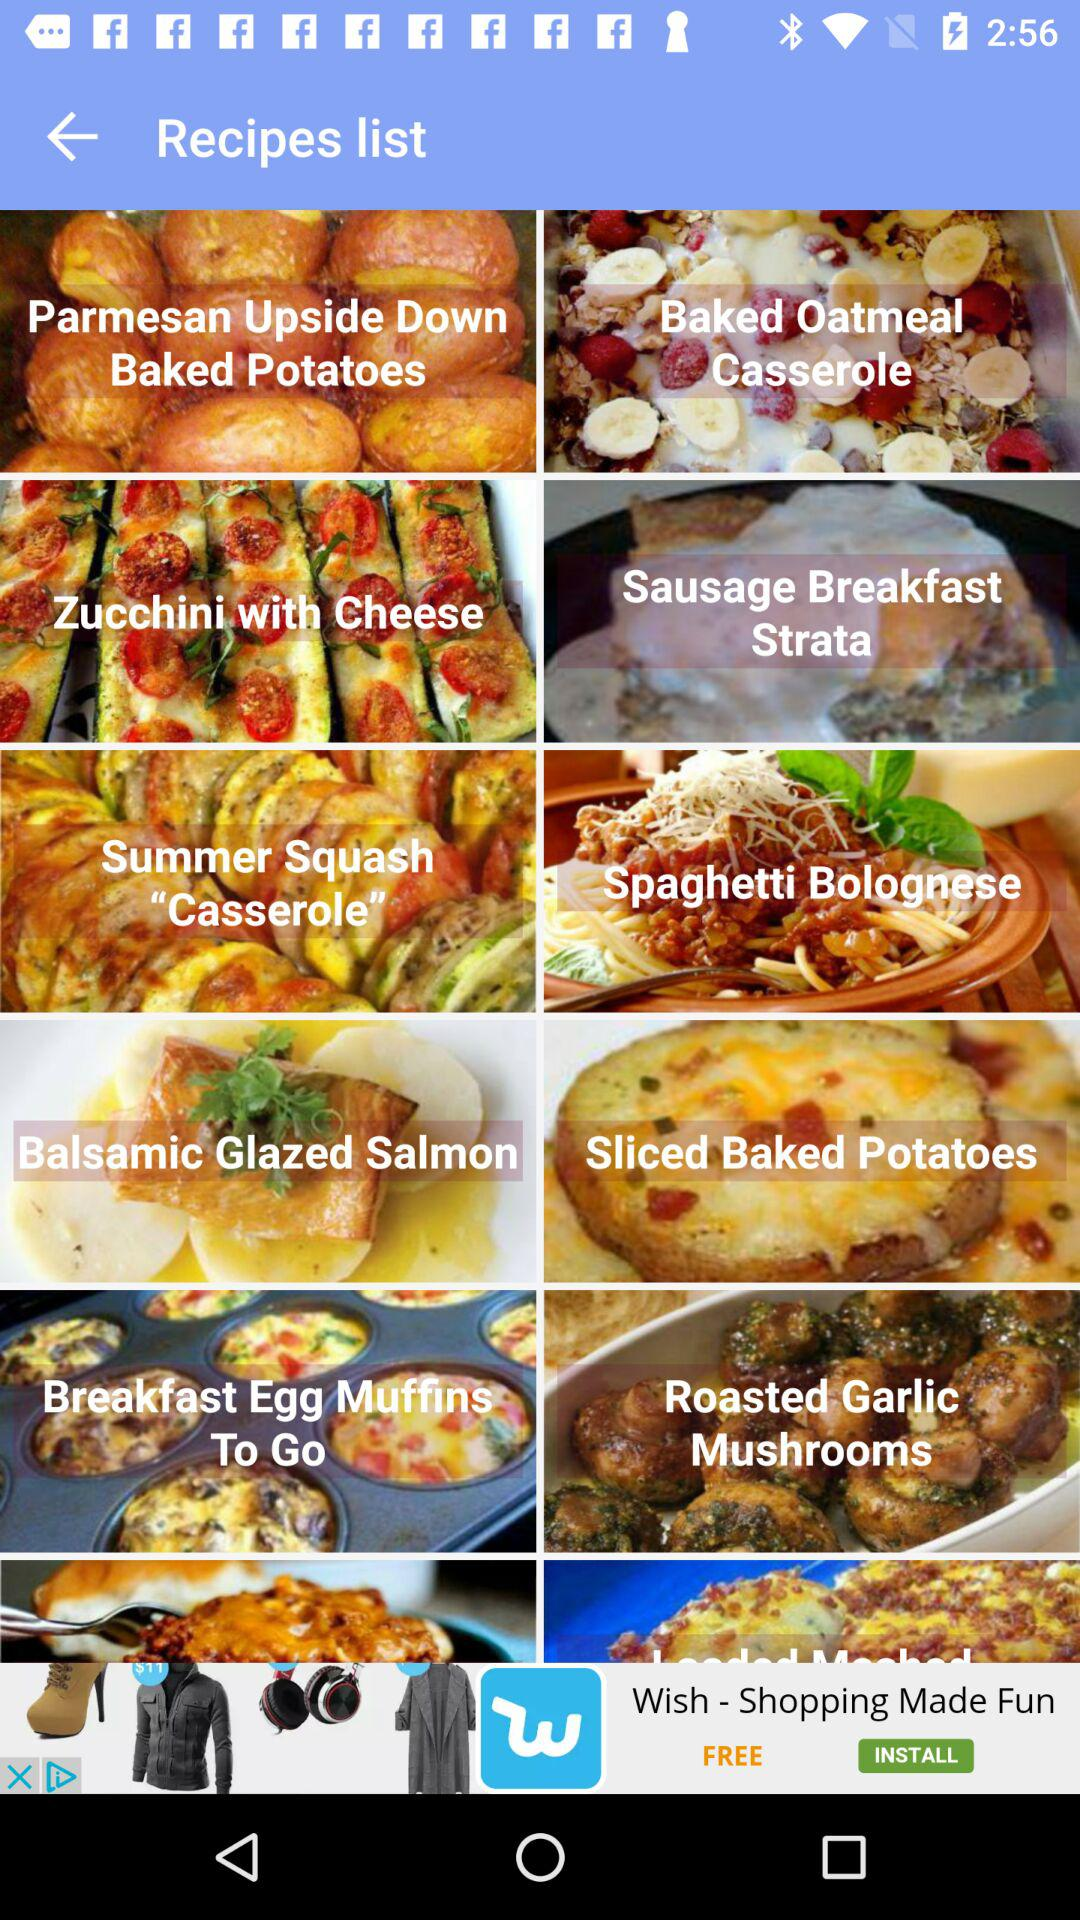What are the different types of recipes available? The different types of recipes available are: "Parmesan Upside Down Baked Potatoes", "Baked Oatmeal Casserole", "Zucchini with Cheese", "Sausage Breakfast Strata", "Summer Squash "Casserole"", "Spaghetti Bolognese", "Balsamic Glazed Salmon", "Sliced Baked Potatoes", "Breakfast Egg Muffins To Go", "Roasted Garlic Mushrooms". 